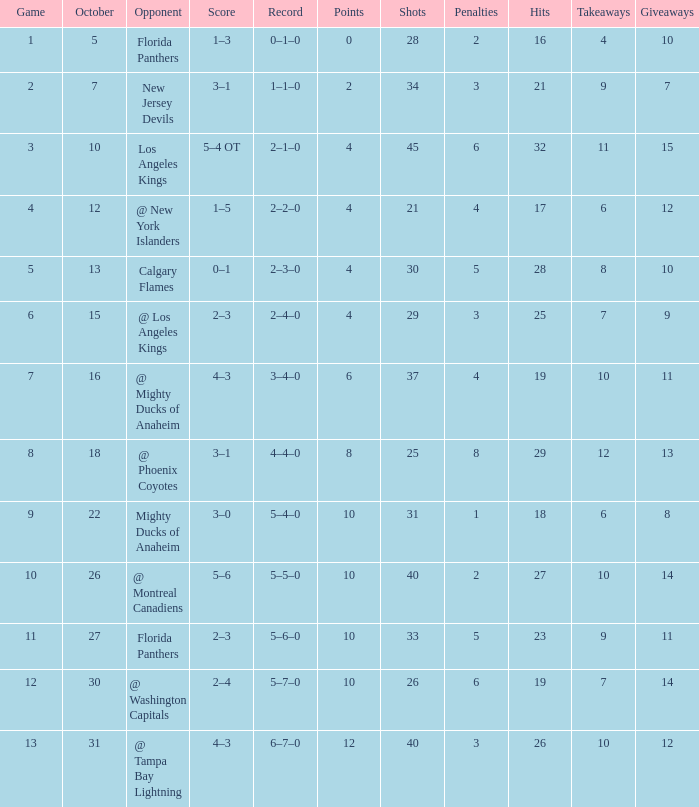Would you mind parsing the complete table? {'header': ['Game', 'October', 'Opponent', 'Score', 'Record', 'Points', 'Shots', 'Penalties', 'Hits', 'Takeaways', 'Giveaways'], 'rows': [['1', '5', 'Florida Panthers', '1–3', '0–1–0', '0', '28', '2', '16', '4', '10'], ['2', '7', 'New Jersey Devils', '3–1', '1–1–0', '2', '34', '3', '21', '9', '7'], ['3', '10', 'Los Angeles Kings', '5–4 OT', '2–1–0', '4', '45', '6', '32', '11', '15'], ['4', '12', '@ New York Islanders', '1–5', '2–2–0', '4', '21', '4', '17', '6', '12'], ['5', '13', 'Calgary Flames', '0–1', '2–3–0', '4', '30', '5', '28', '8', '10'], ['6', '15', '@ Los Angeles Kings', '2–3', '2–4–0', '4', '29', '3', '25', '7', '9'], ['7', '16', '@ Mighty Ducks of Anaheim', '4–3', '3–4–0', '6', '37', '4', '19', '10', '11'], ['8', '18', '@ Phoenix Coyotes', '3–1', '4–4–0', '8', '25', '8', '29', '12', '13'], ['9', '22', 'Mighty Ducks of Anaheim', '3–0', '5–4–0', '10', '31', '1', '18', '6', '8'], ['10', '26', '@ Montreal Canadiens', '5–6', '5–5–0', '10', '40', '2', '27', '10', '14'], ['11', '27', 'Florida Panthers', '2–3', '5–6–0', '10', '33', '5', '23', '9', '11'], ['12', '30', '@ Washington Capitals', '2–4', '5–7–0', '10', '26', '6', '19', '7', '14'], ['13', '31', '@ Tampa Bay Lightning', '4–3', '6–7–0', '12', '40', '3', '26', '10', '12']]} What team has a score of 2 3–1. 